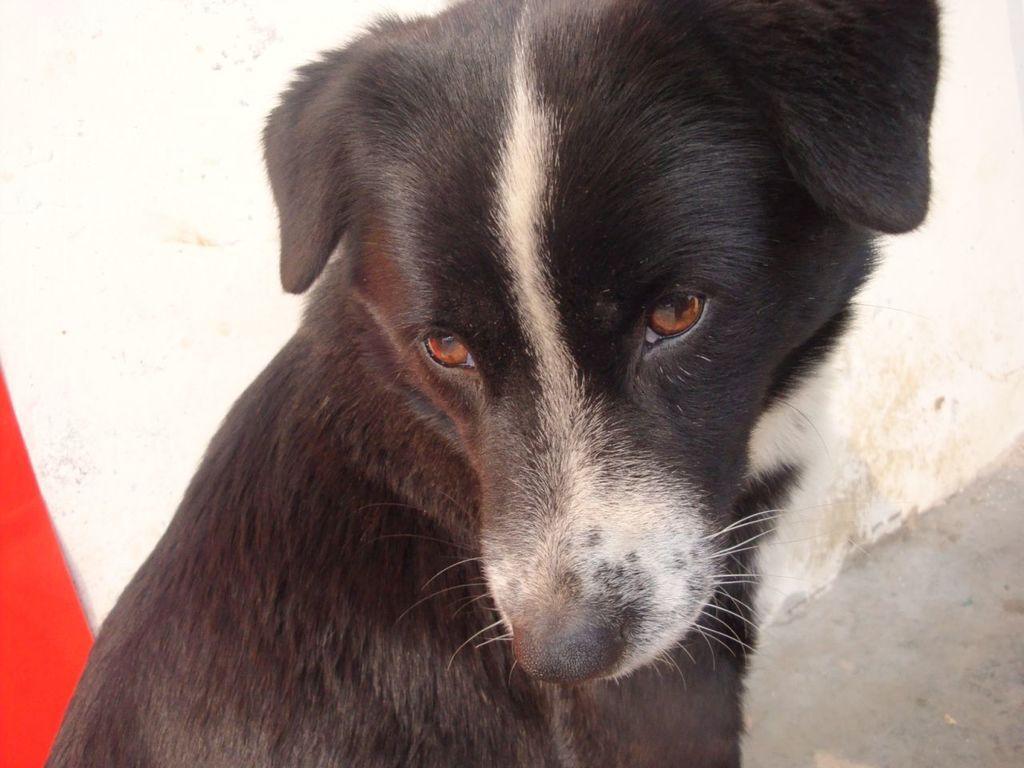In one or two sentences, can you explain what this image depicts? In this picture I can see there is a dog sitting and it is in black color and in the backdrop I can see there is a white wall and a red object. 